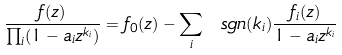Convert formula to latex. <formula><loc_0><loc_0><loc_500><loc_500>\frac { f ( z ) } { \prod _ { i } ( 1 - a _ { i } z ^ { k _ { i } } ) } = f _ { 0 } ( z ) - \sum _ { i } \ s g n ( k _ { i } ) \frac { f _ { i } ( z ) } { 1 - a _ { i } z ^ { k _ { i } } }</formula> 